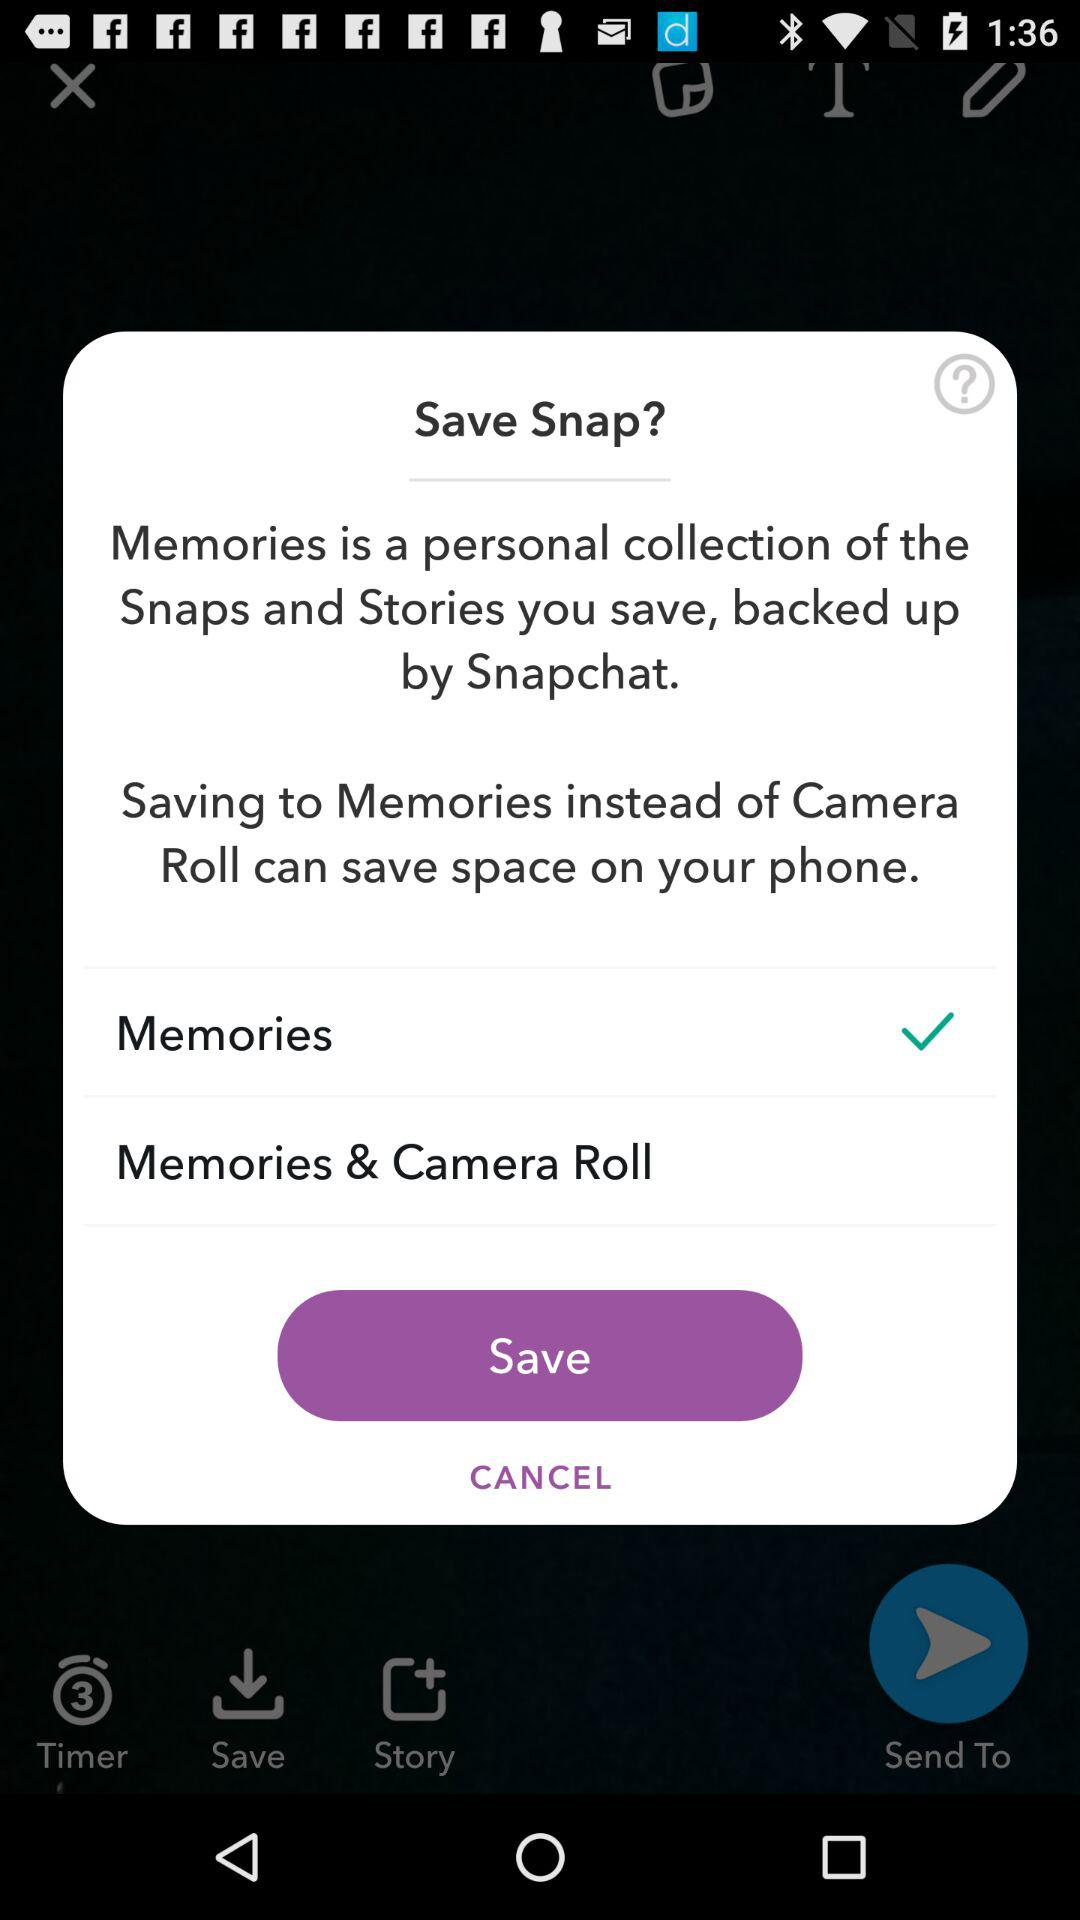Where are the snaps and stories backed up? The snaps and stories backed up by Snapchat. 